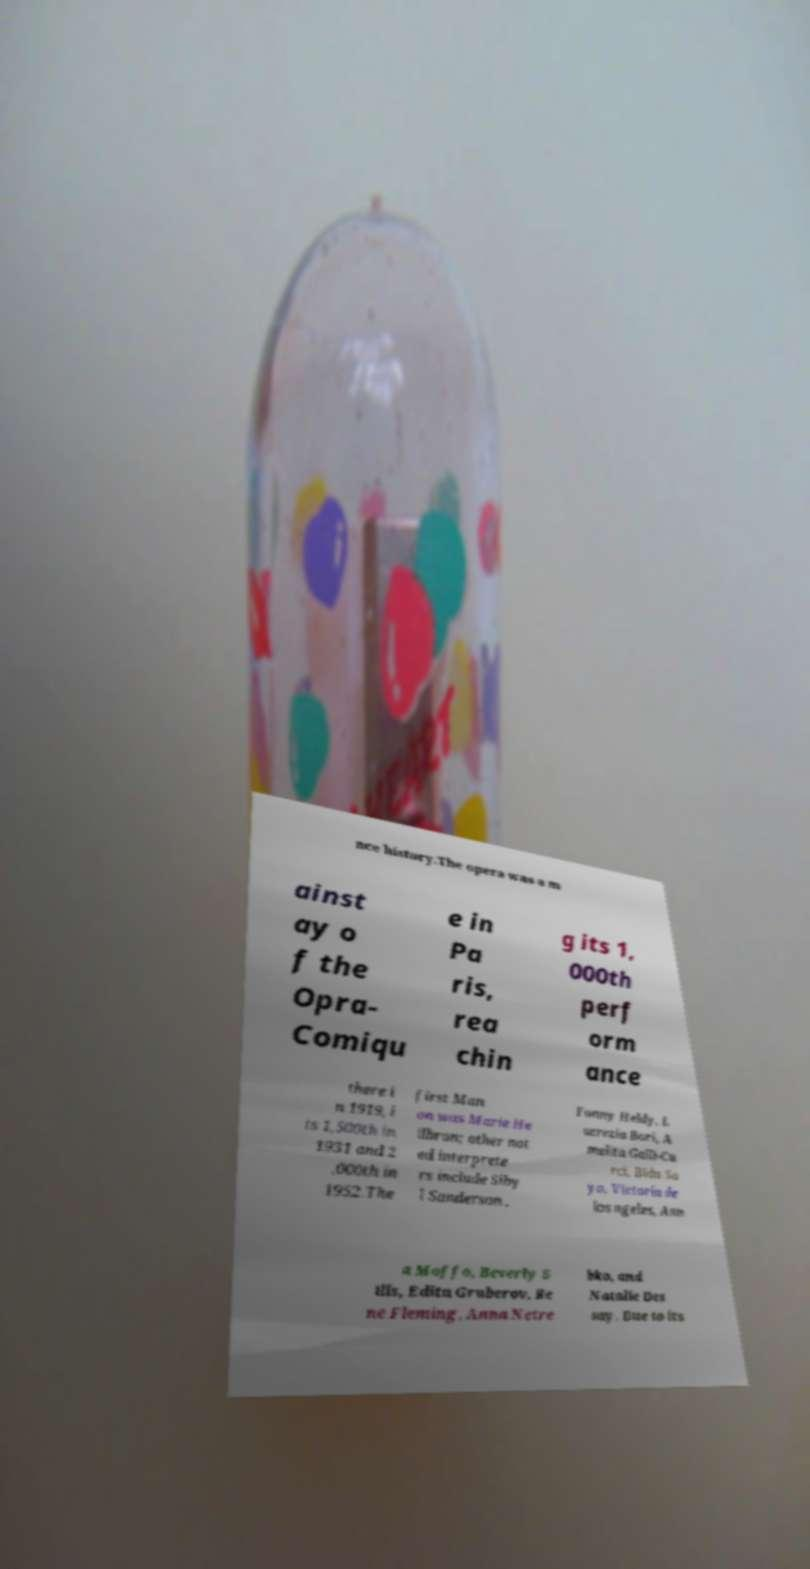There's text embedded in this image that I need extracted. Can you transcribe it verbatim? nce history.The opera was a m ainst ay o f the Opra- Comiqu e in Pa ris, rea chin g its 1, 000th perf orm ance there i n 1919, i ts 1,500th in 1931 and 2 ,000th in 1952.The first Man on was Marie He ilbron; other not ed interprete rs include Siby l Sanderson , Fanny Heldy, L ucrezia Bori, A melita Galli-Cu rci, Bidu Sa yo, Victoria de los ngeles, Ann a Moffo, Beverly S ills, Edita Gruberov, Re ne Fleming, Anna Netre bko, and Natalie Des say. Due to its 